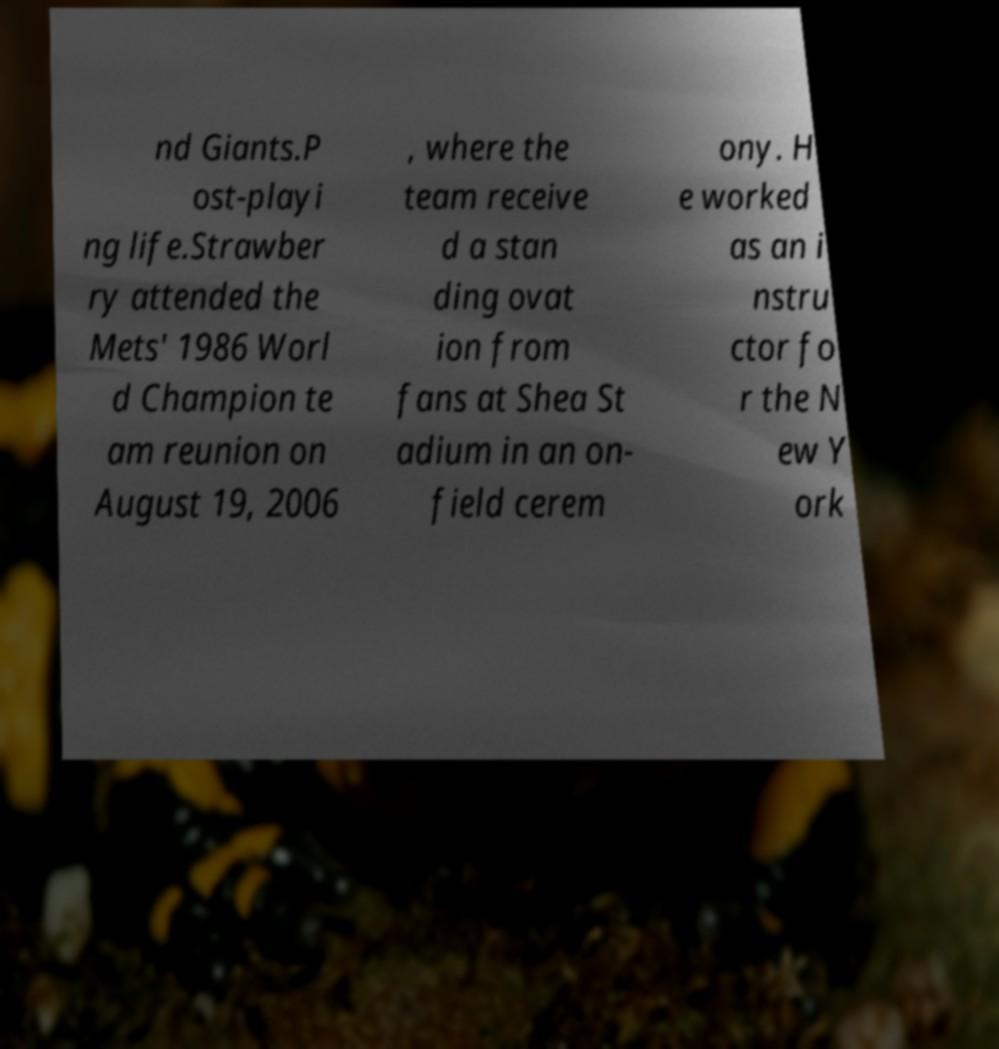Could you extract and type out the text from this image? nd Giants.P ost-playi ng life.Strawber ry attended the Mets' 1986 Worl d Champion te am reunion on August 19, 2006 , where the team receive d a stan ding ovat ion from fans at Shea St adium in an on- field cerem ony. H e worked as an i nstru ctor fo r the N ew Y ork 